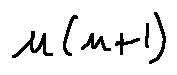<formula> <loc_0><loc_0><loc_500><loc_500>u ( n + 1 )</formula> 